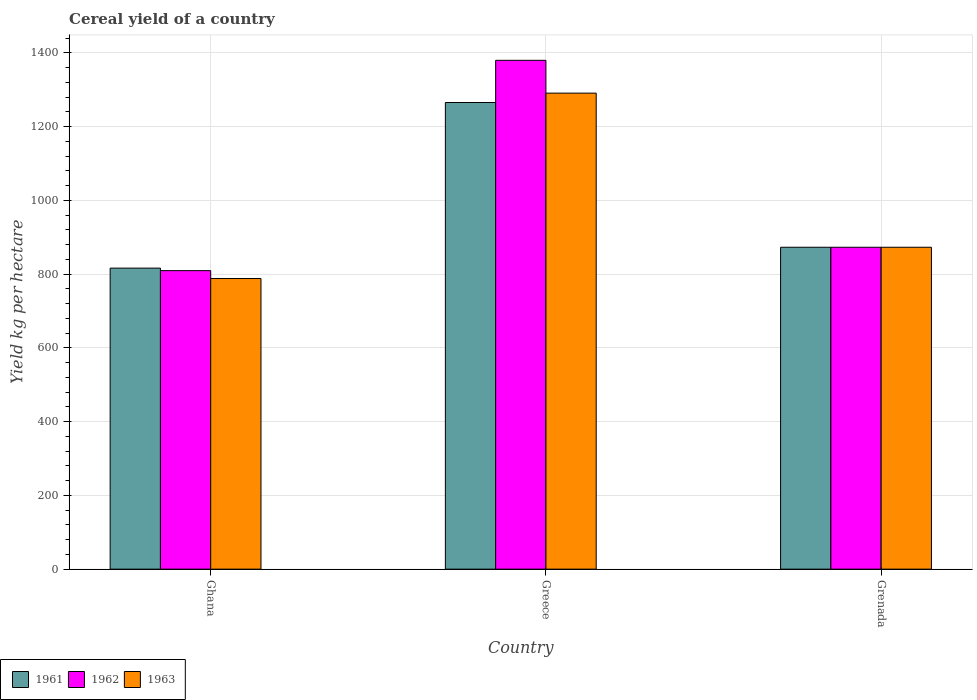How many different coloured bars are there?
Offer a very short reply. 3. Are the number of bars on each tick of the X-axis equal?
Your answer should be compact. Yes. How many bars are there on the 1st tick from the left?
Provide a succinct answer. 3. What is the label of the 3rd group of bars from the left?
Provide a short and direct response. Grenada. What is the total cereal yield in 1963 in Grenada?
Provide a succinct answer. 873.02. Across all countries, what is the maximum total cereal yield in 1961?
Offer a very short reply. 1265.62. Across all countries, what is the minimum total cereal yield in 1962?
Provide a succinct answer. 809.62. In which country was the total cereal yield in 1963 minimum?
Ensure brevity in your answer.  Ghana. What is the total total cereal yield in 1963 in the graph?
Offer a terse response. 2952.26. What is the difference between the total cereal yield in 1961 in Ghana and that in Greece?
Keep it short and to the point. -449.18. What is the difference between the total cereal yield in 1961 in Greece and the total cereal yield in 1962 in Ghana?
Your response must be concise. 456. What is the average total cereal yield in 1961 per country?
Offer a terse response. 985.02. What is the difference between the total cereal yield of/in 1962 and total cereal yield of/in 1963 in Greece?
Make the answer very short. 89.01. In how many countries, is the total cereal yield in 1961 greater than 1360 kg per hectare?
Offer a very short reply. 0. What is the ratio of the total cereal yield in 1963 in Greece to that in Grenada?
Provide a short and direct response. 1.48. What is the difference between the highest and the second highest total cereal yield in 1963?
Provide a succinct answer. -418. What is the difference between the highest and the lowest total cereal yield in 1963?
Your answer should be compact. 502.78. Is the sum of the total cereal yield in 1962 in Greece and Grenada greater than the maximum total cereal yield in 1961 across all countries?
Offer a very short reply. Yes. Is it the case that in every country, the sum of the total cereal yield in 1963 and total cereal yield in 1961 is greater than the total cereal yield in 1962?
Offer a very short reply. Yes. How many countries are there in the graph?
Your answer should be compact. 3. What is the difference between two consecutive major ticks on the Y-axis?
Provide a succinct answer. 200. Are the values on the major ticks of Y-axis written in scientific E-notation?
Keep it short and to the point. No. Does the graph contain any zero values?
Ensure brevity in your answer.  No. Where does the legend appear in the graph?
Provide a succinct answer. Bottom left. What is the title of the graph?
Your answer should be very brief. Cereal yield of a country. Does "1987" appear as one of the legend labels in the graph?
Offer a terse response. No. What is the label or title of the Y-axis?
Provide a succinct answer. Yield kg per hectare. What is the Yield kg per hectare of 1961 in Ghana?
Ensure brevity in your answer.  816.44. What is the Yield kg per hectare in 1962 in Ghana?
Your answer should be very brief. 809.62. What is the Yield kg per hectare of 1963 in Ghana?
Your answer should be very brief. 788.23. What is the Yield kg per hectare in 1961 in Greece?
Offer a terse response. 1265.62. What is the Yield kg per hectare in 1962 in Greece?
Make the answer very short. 1380.03. What is the Yield kg per hectare in 1963 in Greece?
Your answer should be very brief. 1291.01. What is the Yield kg per hectare in 1961 in Grenada?
Your answer should be very brief. 873.02. What is the Yield kg per hectare in 1962 in Grenada?
Your answer should be very brief. 873.02. What is the Yield kg per hectare in 1963 in Grenada?
Give a very brief answer. 873.02. Across all countries, what is the maximum Yield kg per hectare in 1961?
Your response must be concise. 1265.62. Across all countries, what is the maximum Yield kg per hectare in 1962?
Your response must be concise. 1380.03. Across all countries, what is the maximum Yield kg per hectare of 1963?
Provide a short and direct response. 1291.01. Across all countries, what is the minimum Yield kg per hectare of 1961?
Give a very brief answer. 816.44. Across all countries, what is the minimum Yield kg per hectare in 1962?
Offer a very short reply. 809.62. Across all countries, what is the minimum Yield kg per hectare in 1963?
Provide a succinct answer. 788.23. What is the total Yield kg per hectare in 1961 in the graph?
Make the answer very short. 2955.07. What is the total Yield kg per hectare in 1962 in the graph?
Provide a short and direct response. 3062.66. What is the total Yield kg per hectare in 1963 in the graph?
Keep it short and to the point. 2952.26. What is the difference between the Yield kg per hectare in 1961 in Ghana and that in Greece?
Give a very brief answer. -449.18. What is the difference between the Yield kg per hectare in 1962 in Ghana and that in Greece?
Your response must be concise. -570.41. What is the difference between the Yield kg per hectare of 1963 in Ghana and that in Greece?
Your answer should be compact. -502.78. What is the difference between the Yield kg per hectare in 1961 in Ghana and that in Grenada?
Offer a terse response. -56.58. What is the difference between the Yield kg per hectare of 1962 in Ghana and that in Grenada?
Offer a very short reply. -63.4. What is the difference between the Yield kg per hectare of 1963 in Ghana and that in Grenada?
Your answer should be very brief. -84.78. What is the difference between the Yield kg per hectare in 1961 in Greece and that in Grenada?
Your answer should be compact. 392.6. What is the difference between the Yield kg per hectare in 1962 in Greece and that in Grenada?
Keep it short and to the point. 507.01. What is the difference between the Yield kg per hectare of 1963 in Greece and that in Grenada?
Your answer should be very brief. 418. What is the difference between the Yield kg per hectare in 1961 in Ghana and the Yield kg per hectare in 1962 in Greece?
Ensure brevity in your answer.  -563.59. What is the difference between the Yield kg per hectare of 1961 in Ghana and the Yield kg per hectare of 1963 in Greece?
Ensure brevity in your answer.  -474.58. What is the difference between the Yield kg per hectare in 1962 in Ghana and the Yield kg per hectare in 1963 in Greece?
Your response must be concise. -481.4. What is the difference between the Yield kg per hectare of 1961 in Ghana and the Yield kg per hectare of 1962 in Grenada?
Your answer should be very brief. -56.58. What is the difference between the Yield kg per hectare in 1961 in Ghana and the Yield kg per hectare in 1963 in Grenada?
Your answer should be compact. -56.58. What is the difference between the Yield kg per hectare in 1962 in Ghana and the Yield kg per hectare in 1963 in Grenada?
Your answer should be compact. -63.4. What is the difference between the Yield kg per hectare of 1961 in Greece and the Yield kg per hectare of 1962 in Grenada?
Ensure brevity in your answer.  392.6. What is the difference between the Yield kg per hectare in 1961 in Greece and the Yield kg per hectare in 1963 in Grenada?
Give a very brief answer. 392.6. What is the difference between the Yield kg per hectare in 1962 in Greece and the Yield kg per hectare in 1963 in Grenada?
Your response must be concise. 507.01. What is the average Yield kg per hectare of 1961 per country?
Give a very brief answer. 985.02. What is the average Yield kg per hectare in 1962 per country?
Keep it short and to the point. 1020.89. What is the average Yield kg per hectare in 1963 per country?
Offer a terse response. 984.09. What is the difference between the Yield kg per hectare in 1961 and Yield kg per hectare in 1962 in Ghana?
Ensure brevity in your answer.  6.82. What is the difference between the Yield kg per hectare in 1961 and Yield kg per hectare in 1963 in Ghana?
Provide a succinct answer. 28.2. What is the difference between the Yield kg per hectare in 1962 and Yield kg per hectare in 1963 in Ghana?
Provide a short and direct response. 21.38. What is the difference between the Yield kg per hectare in 1961 and Yield kg per hectare in 1962 in Greece?
Give a very brief answer. -114.41. What is the difference between the Yield kg per hectare in 1961 and Yield kg per hectare in 1963 in Greece?
Ensure brevity in your answer.  -25.4. What is the difference between the Yield kg per hectare in 1962 and Yield kg per hectare in 1963 in Greece?
Provide a succinct answer. 89.01. What is the difference between the Yield kg per hectare of 1962 and Yield kg per hectare of 1963 in Grenada?
Your answer should be compact. 0. What is the ratio of the Yield kg per hectare of 1961 in Ghana to that in Greece?
Your response must be concise. 0.65. What is the ratio of the Yield kg per hectare in 1962 in Ghana to that in Greece?
Offer a terse response. 0.59. What is the ratio of the Yield kg per hectare of 1963 in Ghana to that in Greece?
Give a very brief answer. 0.61. What is the ratio of the Yield kg per hectare in 1961 in Ghana to that in Grenada?
Keep it short and to the point. 0.94. What is the ratio of the Yield kg per hectare of 1962 in Ghana to that in Grenada?
Give a very brief answer. 0.93. What is the ratio of the Yield kg per hectare in 1963 in Ghana to that in Grenada?
Give a very brief answer. 0.9. What is the ratio of the Yield kg per hectare in 1961 in Greece to that in Grenada?
Your answer should be very brief. 1.45. What is the ratio of the Yield kg per hectare of 1962 in Greece to that in Grenada?
Your answer should be compact. 1.58. What is the ratio of the Yield kg per hectare in 1963 in Greece to that in Grenada?
Your response must be concise. 1.48. What is the difference between the highest and the second highest Yield kg per hectare of 1961?
Keep it short and to the point. 392.6. What is the difference between the highest and the second highest Yield kg per hectare in 1962?
Give a very brief answer. 507.01. What is the difference between the highest and the second highest Yield kg per hectare of 1963?
Your answer should be very brief. 418. What is the difference between the highest and the lowest Yield kg per hectare of 1961?
Give a very brief answer. 449.18. What is the difference between the highest and the lowest Yield kg per hectare of 1962?
Your answer should be compact. 570.41. What is the difference between the highest and the lowest Yield kg per hectare of 1963?
Provide a succinct answer. 502.78. 